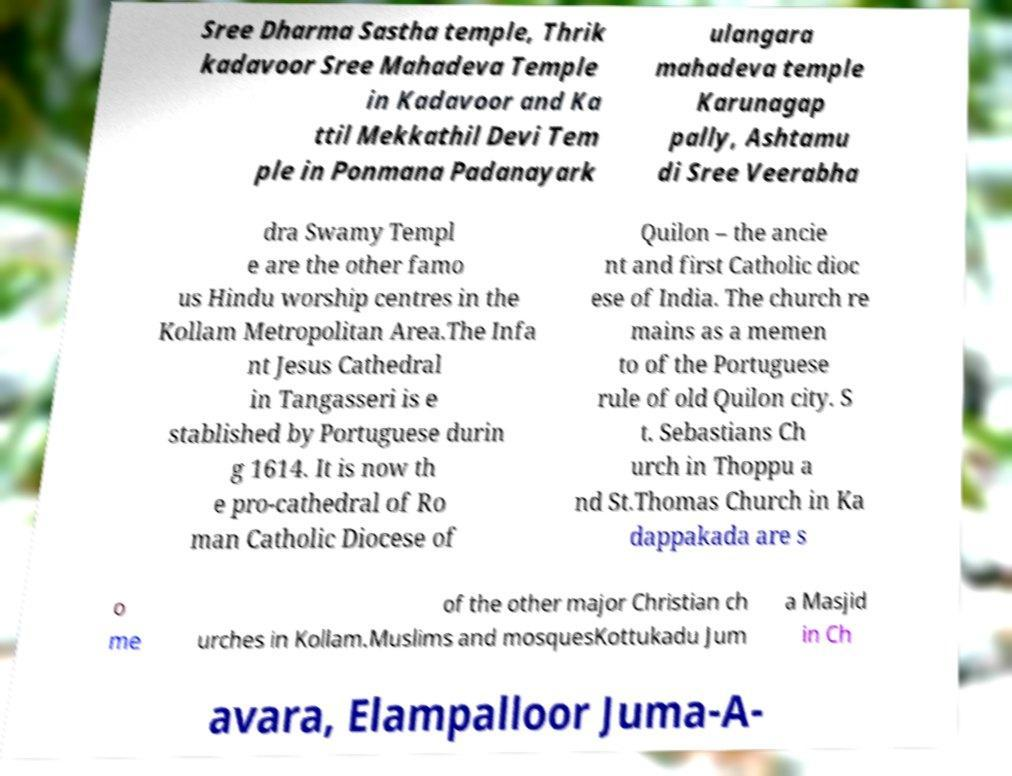Could you assist in decoding the text presented in this image and type it out clearly? Sree Dharma Sastha temple, Thrik kadavoor Sree Mahadeva Temple in Kadavoor and Ka ttil Mekkathil Devi Tem ple in Ponmana Padanayark ulangara mahadeva temple Karunagap pally, Ashtamu di Sree Veerabha dra Swamy Templ e are the other famo us Hindu worship centres in the Kollam Metropolitan Area.The Infa nt Jesus Cathedral in Tangasseri is e stablished by Portuguese durin g 1614. It is now th e pro-cathedral of Ro man Catholic Diocese of Quilon – the ancie nt and first Catholic dioc ese of India. The church re mains as a memen to of the Portuguese rule of old Quilon city. S t. Sebastians Ch urch in Thoppu a nd St.Thomas Church in Ka dappakada are s o me of the other major Christian ch urches in Kollam.Muslims and mosquesKottukadu Jum a Masjid in Ch avara, Elampalloor Juma-A- 